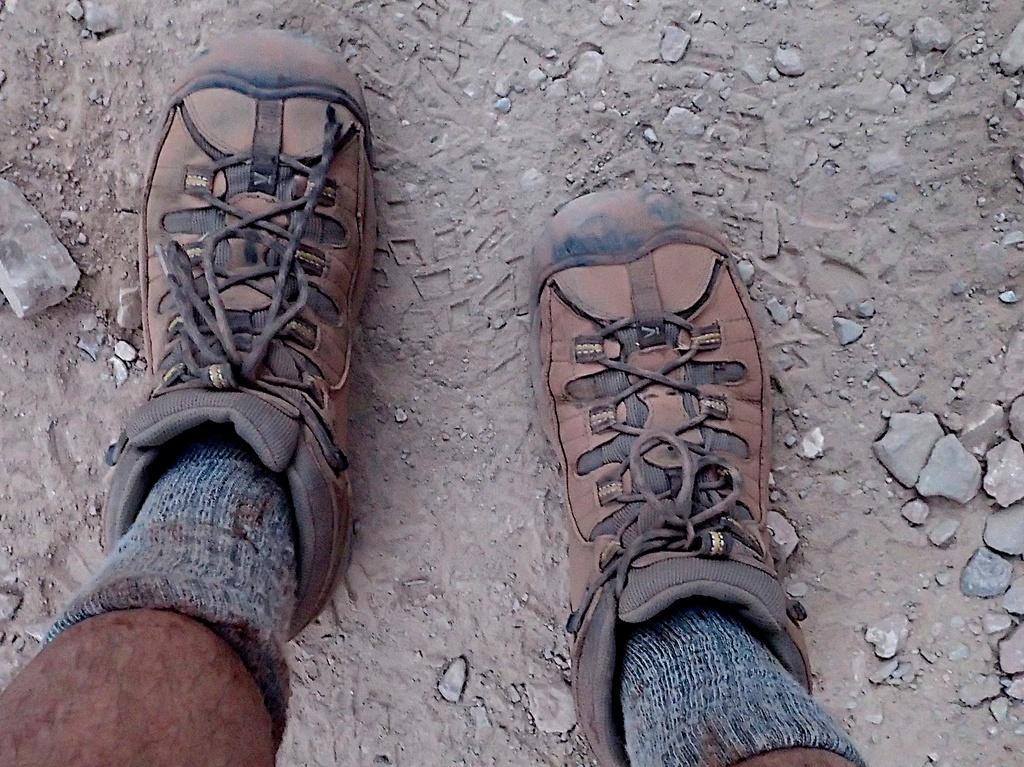Who or what is present in the image? There is a person in the image. What part of the person's body can be seen? The person's legs are visible in the image. What type of shoes is the person wearing? The person is wearing shoes with laces. What else is the person wearing on their feet? The person is wearing socks. What can be seen in the background of the image? There are stones and ground visible in the background of the image. What type of mine is visible in the image? There is no mine present in the image; it features a person with visible legs, shoes with laces, and socks, with a background of stones and ground. 